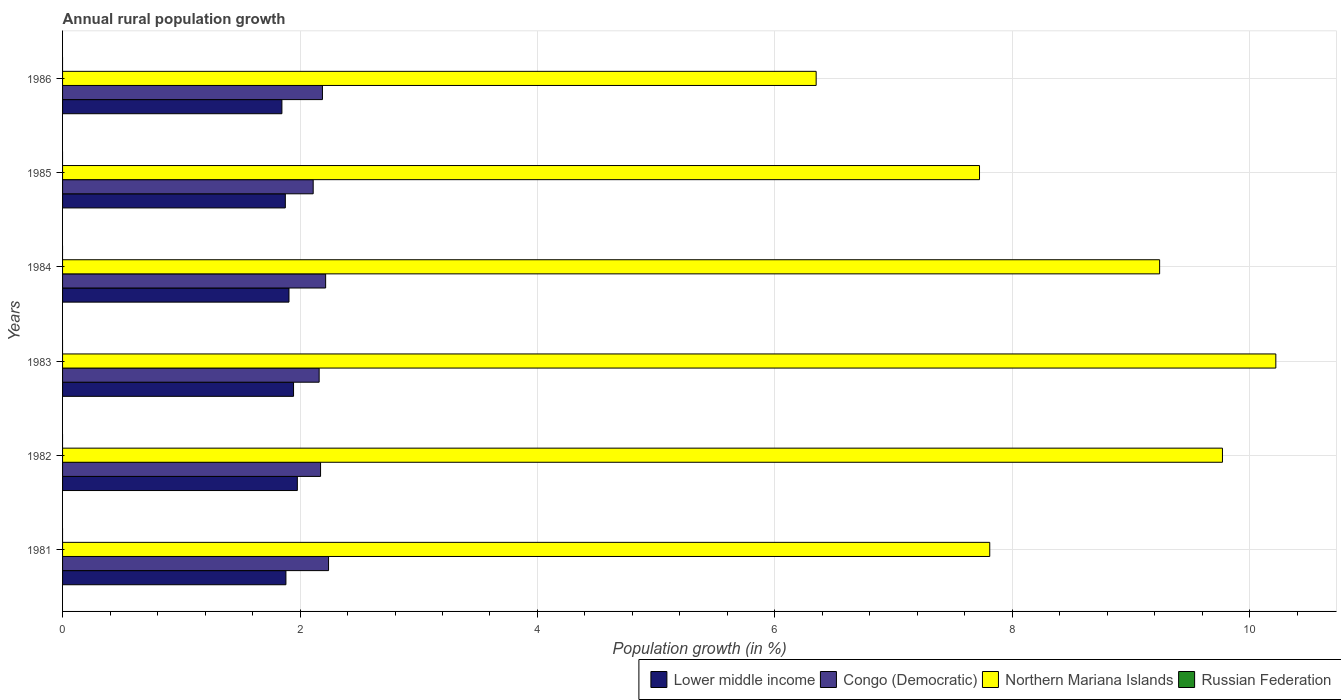How many groups of bars are there?
Your response must be concise. 6. Are the number of bars per tick equal to the number of legend labels?
Provide a short and direct response. No. Are the number of bars on each tick of the Y-axis equal?
Your response must be concise. Yes. How many bars are there on the 1st tick from the bottom?
Give a very brief answer. 3. What is the percentage of rural population growth in Congo (Democratic) in 1983?
Provide a short and direct response. 2.16. Across all years, what is the maximum percentage of rural population growth in Northern Mariana Islands?
Provide a short and direct response. 10.22. What is the total percentage of rural population growth in Congo (Democratic) in the graph?
Make the answer very short. 13.09. What is the difference between the percentage of rural population growth in Lower middle income in 1981 and that in 1982?
Provide a short and direct response. -0.1. What is the difference between the percentage of rural population growth in Congo (Democratic) in 1981 and the percentage of rural population growth in Lower middle income in 1986?
Keep it short and to the point. 0.39. What is the average percentage of rural population growth in Lower middle income per year?
Your answer should be very brief. 1.91. In the year 1984, what is the difference between the percentage of rural population growth in Lower middle income and percentage of rural population growth in Northern Mariana Islands?
Ensure brevity in your answer.  -7.33. In how many years, is the percentage of rural population growth in Lower middle income greater than 4 %?
Provide a succinct answer. 0. What is the ratio of the percentage of rural population growth in Lower middle income in 1982 to that in 1983?
Provide a succinct answer. 1.02. Is the difference between the percentage of rural population growth in Lower middle income in 1985 and 1986 greater than the difference between the percentage of rural population growth in Northern Mariana Islands in 1985 and 1986?
Your answer should be compact. No. What is the difference between the highest and the second highest percentage of rural population growth in Northern Mariana Islands?
Offer a very short reply. 0.45. What is the difference between the highest and the lowest percentage of rural population growth in Congo (Democratic)?
Offer a terse response. 0.13. Are all the bars in the graph horizontal?
Offer a very short reply. Yes. What is the difference between two consecutive major ticks on the X-axis?
Offer a terse response. 2. Are the values on the major ticks of X-axis written in scientific E-notation?
Keep it short and to the point. No. How many legend labels are there?
Keep it short and to the point. 4. What is the title of the graph?
Your answer should be very brief. Annual rural population growth. What is the label or title of the X-axis?
Provide a succinct answer. Population growth (in %). What is the label or title of the Y-axis?
Your answer should be compact. Years. What is the Population growth (in %) in Lower middle income in 1981?
Ensure brevity in your answer.  1.88. What is the Population growth (in %) in Congo (Democratic) in 1981?
Your answer should be very brief. 2.24. What is the Population growth (in %) of Northern Mariana Islands in 1981?
Give a very brief answer. 7.81. What is the Population growth (in %) in Lower middle income in 1982?
Ensure brevity in your answer.  1.98. What is the Population growth (in %) of Congo (Democratic) in 1982?
Ensure brevity in your answer.  2.17. What is the Population growth (in %) in Northern Mariana Islands in 1982?
Make the answer very short. 9.77. What is the Population growth (in %) of Russian Federation in 1982?
Give a very brief answer. 0. What is the Population growth (in %) of Lower middle income in 1983?
Offer a terse response. 1.95. What is the Population growth (in %) of Congo (Democratic) in 1983?
Your answer should be very brief. 2.16. What is the Population growth (in %) of Northern Mariana Islands in 1983?
Give a very brief answer. 10.22. What is the Population growth (in %) in Lower middle income in 1984?
Provide a short and direct response. 1.91. What is the Population growth (in %) of Congo (Democratic) in 1984?
Give a very brief answer. 2.22. What is the Population growth (in %) of Northern Mariana Islands in 1984?
Make the answer very short. 9.24. What is the Population growth (in %) of Russian Federation in 1984?
Your response must be concise. 0. What is the Population growth (in %) of Lower middle income in 1985?
Provide a succinct answer. 1.88. What is the Population growth (in %) in Congo (Democratic) in 1985?
Ensure brevity in your answer.  2.11. What is the Population growth (in %) of Northern Mariana Islands in 1985?
Provide a succinct answer. 7.72. What is the Population growth (in %) in Russian Federation in 1985?
Offer a terse response. 0. What is the Population growth (in %) in Lower middle income in 1986?
Ensure brevity in your answer.  1.85. What is the Population growth (in %) in Congo (Democratic) in 1986?
Offer a terse response. 2.19. What is the Population growth (in %) of Northern Mariana Islands in 1986?
Make the answer very short. 6.35. What is the Population growth (in %) in Russian Federation in 1986?
Offer a very short reply. 0. Across all years, what is the maximum Population growth (in %) of Lower middle income?
Ensure brevity in your answer.  1.98. Across all years, what is the maximum Population growth (in %) of Congo (Democratic)?
Your answer should be compact. 2.24. Across all years, what is the maximum Population growth (in %) in Northern Mariana Islands?
Keep it short and to the point. 10.22. Across all years, what is the minimum Population growth (in %) of Lower middle income?
Offer a very short reply. 1.85. Across all years, what is the minimum Population growth (in %) of Congo (Democratic)?
Offer a very short reply. 2.11. Across all years, what is the minimum Population growth (in %) of Northern Mariana Islands?
Your response must be concise. 6.35. What is the total Population growth (in %) of Lower middle income in the graph?
Provide a short and direct response. 11.44. What is the total Population growth (in %) in Congo (Democratic) in the graph?
Offer a very short reply. 13.09. What is the total Population growth (in %) of Northern Mariana Islands in the graph?
Ensure brevity in your answer.  51.11. What is the total Population growth (in %) of Russian Federation in the graph?
Your answer should be compact. 0. What is the difference between the Population growth (in %) in Lower middle income in 1981 and that in 1982?
Your response must be concise. -0.1. What is the difference between the Population growth (in %) of Congo (Democratic) in 1981 and that in 1982?
Your answer should be compact. 0.07. What is the difference between the Population growth (in %) of Northern Mariana Islands in 1981 and that in 1982?
Your response must be concise. -1.96. What is the difference between the Population growth (in %) of Lower middle income in 1981 and that in 1983?
Ensure brevity in your answer.  -0.06. What is the difference between the Population growth (in %) of Congo (Democratic) in 1981 and that in 1983?
Provide a succinct answer. 0.08. What is the difference between the Population growth (in %) in Northern Mariana Islands in 1981 and that in 1983?
Provide a succinct answer. -2.41. What is the difference between the Population growth (in %) in Lower middle income in 1981 and that in 1984?
Provide a succinct answer. -0.03. What is the difference between the Population growth (in %) of Congo (Democratic) in 1981 and that in 1984?
Ensure brevity in your answer.  0.02. What is the difference between the Population growth (in %) in Northern Mariana Islands in 1981 and that in 1984?
Keep it short and to the point. -1.43. What is the difference between the Population growth (in %) in Lower middle income in 1981 and that in 1985?
Your answer should be compact. 0.01. What is the difference between the Population growth (in %) in Congo (Democratic) in 1981 and that in 1985?
Ensure brevity in your answer.  0.13. What is the difference between the Population growth (in %) in Northern Mariana Islands in 1981 and that in 1985?
Your response must be concise. 0.09. What is the difference between the Population growth (in %) in Lower middle income in 1981 and that in 1986?
Your answer should be very brief. 0.03. What is the difference between the Population growth (in %) of Congo (Democratic) in 1981 and that in 1986?
Provide a succinct answer. 0.05. What is the difference between the Population growth (in %) of Northern Mariana Islands in 1981 and that in 1986?
Provide a succinct answer. 1.46. What is the difference between the Population growth (in %) in Lower middle income in 1982 and that in 1983?
Give a very brief answer. 0.03. What is the difference between the Population growth (in %) in Congo (Democratic) in 1982 and that in 1983?
Make the answer very short. 0.01. What is the difference between the Population growth (in %) in Northern Mariana Islands in 1982 and that in 1983?
Offer a terse response. -0.45. What is the difference between the Population growth (in %) in Lower middle income in 1982 and that in 1984?
Offer a terse response. 0.07. What is the difference between the Population growth (in %) in Congo (Democratic) in 1982 and that in 1984?
Make the answer very short. -0.04. What is the difference between the Population growth (in %) in Northern Mariana Islands in 1982 and that in 1984?
Offer a terse response. 0.53. What is the difference between the Population growth (in %) of Lower middle income in 1982 and that in 1985?
Provide a succinct answer. 0.1. What is the difference between the Population growth (in %) in Congo (Democratic) in 1982 and that in 1985?
Your answer should be compact. 0.06. What is the difference between the Population growth (in %) in Northern Mariana Islands in 1982 and that in 1985?
Make the answer very short. 2.05. What is the difference between the Population growth (in %) in Lower middle income in 1982 and that in 1986?
Your answer should be very brief. 0.13. What is the difference between the Population growth (in %) of Congo (Democratic) in 1982 and that in 1986?
Provide a short and direct response. -0.02. What is the difference between the Population growth (in %) of Northern Mariana Islands in 1982 and that in 1986?
Your answer should be very brief. 3.42. What is the difference between the Population growth (in %) in Lower middle income in 1983 and that in 1984?
Your answer should be very brief. 0.04. What is the difference between the Population growth (in %) in Congo (Democratic) in 1983 and that in 1984?
Provide a short and direct response. -0.05. What is the difference between the Population growth (in %) of Northern Mariana Islands in 1983 and that in 1984?
Your answer should be compact. 0.98. What is the difference between the Population growth (in %) in Lower middle income in 1983 and that in 1985?
Offer a very short reply. 0.07. What is the difference between the Population growth (in %) in Congo (Democratic) in 1983 and that in 1985?
Provide a succinct answer. 0.05. What is the difference between the Population growth (in %) in Northern Mariana Islands in 1983 and that in 1985?
Your answer should be very brief. 2.5. What is the difference between the Population growth (in %) in Lower middle income in 1983 and that in 1986?
Make the answer very short. 0.1. What is the difference between the Population growth (in %) in Congo (Democratic) in 1983 and that in 1986?
Keep it short and to the point. -0.03. What is the difference between the Population growth (in %) in Northern Mariana Islands in 1983 and that in 1986?
Your response must be concise. 3.87. What is the difference between the Population growth (in %) of Lower middle income in 1984 and that in 1985?
Ensure brevity in your answer.  0.03. What is the difference between the Population growth (in %) of Congo (Democratic) in 1984 and that in 1985?
Keep it short and to the point. 0.1. What is the difference between the Population growth (in %) of Northern Mariana Islands in 1984 and that in 1985?
Ensure brevity in your answer.  1.52. What is the difference between the Population growth (in %) of Lower middle income in 1984 and that in 1986?
Offer a very short reply. 0.06. What is the difference between the Population growth (in %) in Congo (Democratic) in 1984 and that in 1986?
Ensure brevity in your answer.  0.03. What is the difference between the Population growth (in %) in Northern Mariana Islands in 1984 and that in 1986?
Offer a terse response. 2.89. What is the difference between the Population growth (in %) in Lower middle income in 1985 and that in 1986?
Give a very brief answer. 0.03. What is the difference between the Population growth (in %) of Congo (Democratic) in 1985 and that in 1986?
Make the answer very short. -0.08. What is the difference between the Population growth (in %) of Northern Mariana Islands in 1985 and that in 1986?
Keep it short and to the point. 1.38. What is the difference between the Population growth (in %) of Lower middle income in 1981 and the Population growth (in %) of Congo (Democratic) in 1982?
Make the answer very short. -0.29. What is the difference between the Population growth (in %) in Lower middle income in 1981 and the Population growth (in %) in Northern Mariana Islands in 1982?
Offer a terse response. -7.89. What is the difference between the Population growth (in %) in Congo (Democratic) in 1981 and the Population growth (in %) in Northern Mariana Islands in 1982?
Keep it short and to the point. -7.53. What is the difference between the Population growth (in %) in Lower middle income in 1981 and the Population growth (in %) in Congo (Democratic) in 1983?
Your answer should be compact. -0.28. What is the difference between the Population growth (in %) in Lower middle income in 1981 and the Population growth (in %) in Northern Mariana Islands in 1983?
Your answer should be very brief. -8.34. What is the difference between the Population growth (in %) of Congo (Democratic) in 1981 and the Population growth (in %) of Northern Mariana Islands in 1983?
Offer a terse response. -7.98. What is the difference between the Population growth (in %) in Lower middle income in 1981 and the Population growth (in %) in Congo (Democratic) in 1984?
Your answer should be very brief. -0.33. What is the difference between the Population growth (in %) of Lower middle income in 1981 and the Population growth (in %) of Northern Mariana Islands in 1984?
Give a very brief answer. -7.36. What is the difference between the Population growth (in %) of Lower middle income in 1981 and the Population growth (in %) of Congo (Democratic) in 1985?
Provide a succinct answer. -0.23. What is the difference between the Population growth (in %) in Lower middle income in 1981 and the Population growth (in %) in Northern Mariana Islands in 1985?
Ensure brevity in your answer.  -5.84. What is the difference between the Population growth (in %) of Congo (Democratic) in 1981 and the Population growth (in %) of Northern Mariana Islands in 1985?
Offer a very short reply. -5.48. What is the difference between the Population growth (in %) in Lower middle income in 1981 and the Population growth (in %) in Congo (Democratic) in 1986?
Provide a succinct answer. -0.31. What is the difference between the Population growth (in %) in Lower middle income in 1981 and the Population growth (in %) in Northern Mariana Islands in 1986?
Keep it short and to the point. -4.47. What is the difference between the Population growth (in %) of Congo (Democratic) in 1981 and the Population growth (in %) of Northern Mariana Islands in 1986?
Offer a terse response. -4.11. What is the difference between the Population growth (in %) in Lower middle income in 1982 and the Population growth (in %) in Congo (Democratic) in 1983?
Your answer should be compact. -0.18. What is the difference between the Population growth (in %) of Lower middle income in 1982 and the Population growth (in %) of Northern Mariana Islands in 1983?
Offer a terse response. -8.24. What is the difference between the Population growth (in %) in Congo (Democratic) in 1982 and the Population growth (in %) in Northern Mariana Islands in 1983?
Provide a succinct answer. -8.05. What is the difference between the Population growth (in %) in Lower middle income in 1982 and the Population growth (in %) in Congo (Democratic) in 1984?
Make the answer very short. -0.24. What is the difference between the Population growth (in %) of Lower middle income in 1982 and the Population growth (in %) of Northern Mariana Islands in 1984?
Your answer should be very brief. -7.26. What is the difference between the Population growth (in %) in Congo (Democratic) in 1982 and the Population growth (in %) in Northern Mariana Islands in 1984?
Your answer should be compact. -7.07. What is the difference between the Population growth (in %) in Lower middle income in 1982 and the Population growth (in %) in Congo (Democratic) in 1985?
Provide a succinct answer. -0.13. What is the difference between the Population growth (in %) in Lower middle income in 1982 and the Population growth (in %) in Northern Mariana Islands in 1985?
Your answer should be compact. -5.75. What is the difference between the Population growth (in %) in Congo (Democratic) in 1982 and the Population growth (in %) in Northern Mariana Islands in 1985?
Your response must be concise. -5.55. What is the difference between the Population growth (in %) of Lower middle income in 1982 and the Population growth (in %) of Congo (Democratic) in 1986?
Offer a terse response. -0.21. What is the difference between the Population growth (in %) of Lower middle income in 1982 and the Population growth (in %) of Northern Mariana Islands in 1986?
Ensure brevity in your answer.  -4.37. What is the difference between the Population growth (in %) of Congo (Democratic) in 1982 and the Population growth (in %) of Northern Mariana Islands in 1986?
Ensure brevity in your answer.  -4.17. What is the difference between the Population growth (in %) in Lower middle income in 1983 and the Population growth (in %) in Congo (Democratic) in 1984?
Your answer should be compact. -0.27. What is the difference between the Population growth (in %) of Lower middle income in 1983 and the Population growth (in %) of Northern Mariana Islands in 1984?
Your answer should be compact. -7.29. What is the difference between the Population growth (in %) of Congo (Democratic) in 1983 and the Population growth (in %) of Northern Mariana Islands in 1984?
Give a very brief answer. -7.08. What is the difference between the Population growth (in %) of Lower middle income in 1983 and the Population growth (in %) of Congo (Democratic) in 1985?
Make the answer very short. -0.17. What is the difference between the Population growth (in %) of Lower middle income in 1983 and the Population growth (in %) of Northern Mariana Islands in 1985?
Give a very brief answer. -5.78. What is the difference between the Population growth (in %) in Congo (Democratic) in 1983 and the Population growth (in %) in Northern Mariana Islands in 1985?
Make the answer very short. -5.56. What is the difference between the Population growth (in %) of Lower middle income in 1983 and the Population growth (in %) of Congo (Democratic) in 1986?
Your answer should be very brief. -0.24. What is the difference between the Population growth (in %) in Lower middle income in 1983 and the Population growth (in %) in Northern Mariana Islands in 1986?
Your answer should be compact. -4.4. What is the difference between the Population growth (in %) in Congo (Democratic) in 1983 and the Population growth (in %) in Northern Mariana Islands in 1986?
Offer a very short reply. -4.19. What is the difference between the Population growth (in %) in Lower middle income in 1984 and the Population growth (in %) in Congo (Democratic) in 1985?
Ensure brevity in your answer.  -0.2. What is the difference between the Population growth (in %) of Lower middle income in 1984 and the Population growth (in %) of Northern Mariana Islands in 1985?
Give a very brief answer. -5.82. What is the difference between the Population growth (in %) in Congo (Democratic) in 1984 and the Population growth (in %) in Northern Mariana Islands in 1985?
Your answer should be very brief. -5.51. What is the difference between the Population growth (in %) of Lower middle income in 1984 and the Population growth (in %) of Congo (Democratic) in 1986?
Give a very brief answer. -0.28. What is the difference between the Population growth (in %) of Lower middle income in 1984 and the Population growth (in %) of Northern Mariana Islands in 1986?
Your answer should be very brief. -4.44. What is the difference between the Population growth (in %) in Congo (Democratic) in 1984 and the Population growth (in %) in Northern Mariana Islands in 1986?
Keep it short and to the point. -4.13. What is the difference between the Population growth (in %) of Lower middle income in 1985 and the Population growth (in %) of Congo (Democratic) in 1986?
Your answer should be very brief. -0.31. What is the difference between the Population growth (in %) in Lower middle income in 1985 and the Population growth (in %) in Northern Mariana Islands in 1986?
Provide a short and direct response. -4.47. What is the difference between the Population growth (in %) of Congo (Democratic) in 1985 and the Population growth (in %) of Northern Mariana Islands in 1986?
Keep it short and to the point. -4.24. What is the average Population growth (in %) of Lower middle income per year?
Offer a very short reply. 1.91. What is the average Population growth (in %) of Congo (Democratic) per year?
Provide a short and direct response. 2.18. What is the average Population growth (in %) of Northern Mariana Islands per year?
Provide a short and direct response. 8.52. What is the average Population growth (in %) of Russian Federation per year?
Provide a short and direct response. 0. In the year 1981, what is the difference between the Population growth (in %) of Lower middle income and Population growth (in %) of Congo (Democratic)?
Ensure brevity in your answer.  -0.36. In the year 1981, what is the difference between the Population growth (in %) in Lower middle income and Population growth (in %) in Northern Mariana Islands?
Make the answer very short. -5.93. In the year 1981, what is the difference between the Population growth (in %) in Congo (Democratic) and Population growth (in %) in Northern Mariana Islands?
Give a very brief answer. -5.57. In the year 1982, what is the difference between the Population growth (in %) in Lower middle income and Population growth (in %) in Congo (Democratic)?
Offer a very short reply. -0.2. In the year 1982, what is the difference between the Population growth (in %) of Lower middle income and Population growth (in %) of Northern Mariana Islands?
Provide a short and direct response. -7.79. In the year 1982, what is the difference between the Population growth (in %) in Congo (Democratic) and Population growth (in %) in Northern Mariana Islands?
Your response must be concise. -7.6. In the year 1983, what is the difference between the Population growth (in %) in Lower middle income and Population growth (in %) in Congo (Democratic)?
Your response must be concise. -0.22. In the year 1983, what is the difference between the Population growth (in %) of Lower middle income and Population growth (in %) of Northern Mariana Islands?
Offer a very short reply. -8.27. In the year 1983, what is the difference between the Population growth (in %) in Congo (Democratic) and Population growth (in %) in Northern Mariana Islands?
Your response must be concise. -8.06. In the year 1984, what is the difference between the Population growth (in %) of Lower middle income and Population growth (in %) of Congo (Democratic)?
Provide a short and direct response. -0.31. In the year 1984, what is the difference between the Population growth (in %) of Lower middle income and Population growth (in %) of Northern Mariana Islands?
Provide a short and direct response. -7.33. In the year 1984, what is the difference between the Population growth (in %) in Congo (Democratic) and Population growth (in %) in Northern Mariana Islands?
Ensure brevity in your answer.  -7.02. In the year 1985, what is the difference between the Population growth (in %) of Lower middle income and Population growth (in %) of Congo (Democratic)?
Provide a succinct answer. -0.23. In the year 1985, what is the difference between the Population growth (in %) in Lower middle income and Population growth (in %) in Northern Mariana Islands?
Provide a succinct answer. -5.85. In the year 1985, what is the difference between the Population growth (in %) in Congo (Democratic) and Population growth (in %) in Northern Mariana Islands?
Your response must be concise. -5.61. In the year 1986, what is the difference between the Population growth (in %) of Lower middle income and Population growth (in %) of Congo (Democratic)?
Offer a very short reply. -0.34. In the year 1986, what is the difference between the Population growth (in %) of Lower middle income and Population growth (in %) of Northern Mariana Islands?
Offer a very short reply. -4.5. In the year 1986, what is the difference between the Population growth (in %) of Congo (Democratic) and Population growth (in %) of Northern Mariana Islands?
Keep it short and to the point. -4.16. What is the ratio of the Population growth (in %) of Lower middle income in 1981 to that in 1982?
Your answer should be compact. 0.95. What is the ratio of the Population growth (in %) in Congo (Democratic) in 1981 to that in 1982?
Provide a short and direct response. 1.03. What is the ratio of the Population growth (in %) in Northern Mariana Islands in 1981 to that in 1982?
Offer a terse response. 0.8. What is the ratio of the Population growth (in %) of Lower middle income in 1981 to that in 1983?
Provide a short and direct response. 0.97. What is the ratio of the Population growth (in %) of Congo (Democratic) in 1981 to that in 1983?
Make the answer very short. 1.04. What is the ratio of the Population growth (in %) in Northern Mariana Islands in 1981 to that in 1983?
Your answer should be compact. 0.76. What is the ratio of the Population growth (in %) of Lower middle income in 1981 to that in 1984?
Your answer should be very brief. 0.99. What is the ratio of the Population growth (in %) in Congo (Democratic) in 1981 to that in 1984?
Provide a succinct answer. 1.01. What is the ratio of the Population growth (in %) in Northern Mariana Islands in 1981 to that in 1984?
Give a very brief answer. 0.85. What is the ratio of the Population growth (in %) of Lower middle income in 1981 to that in 1985?
Your answer should be very brief. 1. What is the ratio of the Population growth (in %) in Congo (Democratic) in 1981 to that in 1985?
Ensure brevity in your answer.  1.06. What is the ratio of the Population growth (in %) in Northern Mariana Islands in 1981 to that in 1985?
Make the answer very short. 1.01. What is the ratio of the Population growth (in %) of Lower middle income in 1981 to that in 1986?
Give a very brief answer. 1.02. What is the ratio of the Population growth (in %) in Congo (Democratic) in 1981 to that in 1986?
Give a very brief answer. 1.02. What is the ratio of the Population growth (in %) in Northern Mariana Islands in 1981 to that in 1986?
Your answer should be compact. 1.23. What is the ratio of the Population growth (in %) in Lower middle income in 1982 to that in 1983?
Offer a terse response. 1.02. What is the ratio of the Population growth (in %) in Congo (Democratic) in 1982 to that in 1983?
Your response must be concise. 1.01. What is the ratio of the Population growth (in %) of Northern Mariana Islands in 1982 to that in 1983?
Offer a terse response. 0.96. What is the ratio of the Population growth (in %) in Lower middle income in 1982 to that in 1984?
Provide a succinct answer. 1.04. What is the ratio of the Population growth (in %) of Congo (Democratic) in 1982 to that in 1984?
Offer a terse response. 0.98. What is the ratio of the Population growth (in %) in Northern Mariana Islands in 1982 to that in 1984?
Ensure brevity in your answer.  1.06. What is the ratio of the Population growth (in %) of Lower middle income in 1982 to that in 1985?
Your answer should be compact. 1.05. What is the ratio of the Population growth (in %) of Congo (Democratic) in 1982 to that in 1985?
Your answer should be very brief. 1.03. What is the ratio of the Population growth (in %) in Northern Mariana Islands in 1982 to that in 1985?
Your response must be concise. 1.26. What is the ratio of the Population growth (in %) in Lower middle income in 1982 to that in 1986?
Provide a short and direct response. 1.07. What is the ratio of the Population growth (in %) of Northern Mariana Islands in 1982 to that in 1986?
Offer a terse response. 1.54. What is the ratio of the Population growth (in %) of Lower middle income in 1983 to that in 1984?
Offer a terse response. 1.02. What is the ratio of the Population growth (in %) in Congo (Democratic) in 1983 to that in 1984?
Give a very brief answer. 0.98. What is the ratio of the Population growth (in %) of Northern Mariana Islands in 1983 to that in 1984?
Give a very brief answer. 1.11. What is the ratio of the Population growth (in %) of Lower middle income in 1983 to that in 1985?
Provide a short and direct response. 1.04. What is the ratio of the Population growth (in %) in Congo (Democratic) in 1983 to that in 1985?
Your response must be concise. 1.02. What is the ratio of the Population growth (in %) of Northern Mariana Islands in 1983 to that in 1985?
Provide a short and direct response. 1.32. What is the ratio of the Population growth (in %) in Lower middle income in 1983 to that in 1986?
Provide a short and direct response. 1.05. What is the ratio of the Population growth (in %) of Congo (Democratic) in 1983 to that in 1986?
Give a very brief answer. 0.99. What is the ratio of the Population growth (in %) of Northern Mariana Islands in 1983 to that in 1986?
Your answer should be compact. 1.61. What is the ratio of the Population growth (in %) in Lower middle income in 1984 to that in 1985?
Ensure brevity in your answer.  1.02. What is the ratio of the Population growth (in %) in Congo (Democratic) in 1984 to that in 1985?
Ensure brevity in your answer.  1.05. What is the ratio of the Population growth (in %) of Northern Mariana Islands in 1984 to that in 1985?
Offer a terse response. 1.2. What is the ratio of the Population growth (in %) in Lower middle income in 1984 to that in 1986?
Offer a terse response. 1.03. What is the ratio of the Population growth (in %) in Congo (Democratic) in 1984 to that in 1986?
Your response must be concise. 1.01. What is the ratio of the Population growth (in %) of Northern Mariana Islands in 1984 to that in 1986?
Provide a succinct answer. 1.46. What is the ratio of the Population growth (in %) in Lower middle income in 1985 to that in 1986?
Your answer should be compact. 1.02. What is the ratio of the Population growth (in %) of Congo (Democratic) in 1985 to that in 1986?
Keep it short and to the point. 0.96. What is the ratio of the Population growth (in %) in Northern Mariana Islands in 1985 to that in 1986?
Keep it short and to the point. 1.22. What is the difference between the highest and the second highest Population growth (in %) in Lower middle income?
Your answer should be very brief. 0.03. What is the difference between the highest and the second highest Population growth (in %) of Congo (Democratic)?
Your response must be concise. 0.02. What is the difference between the highest and the second highest Population growth (in %) in Northern Mariana Islands?
Make the answer very short. 0.45. What is the difference between the highest and the lowest Population growth (in %) in Lower middle income?
Provide a succinct answer. 0.13. What is the difference between the highest and the lowest Population growth (in %) of Congo (Democratic)?
Offer a very short reply. 0.13. What is the difference between the highest and the lowest Population growth (in %) of Northern Mariana Islands?
Provide a short and direct response. 3.87. 